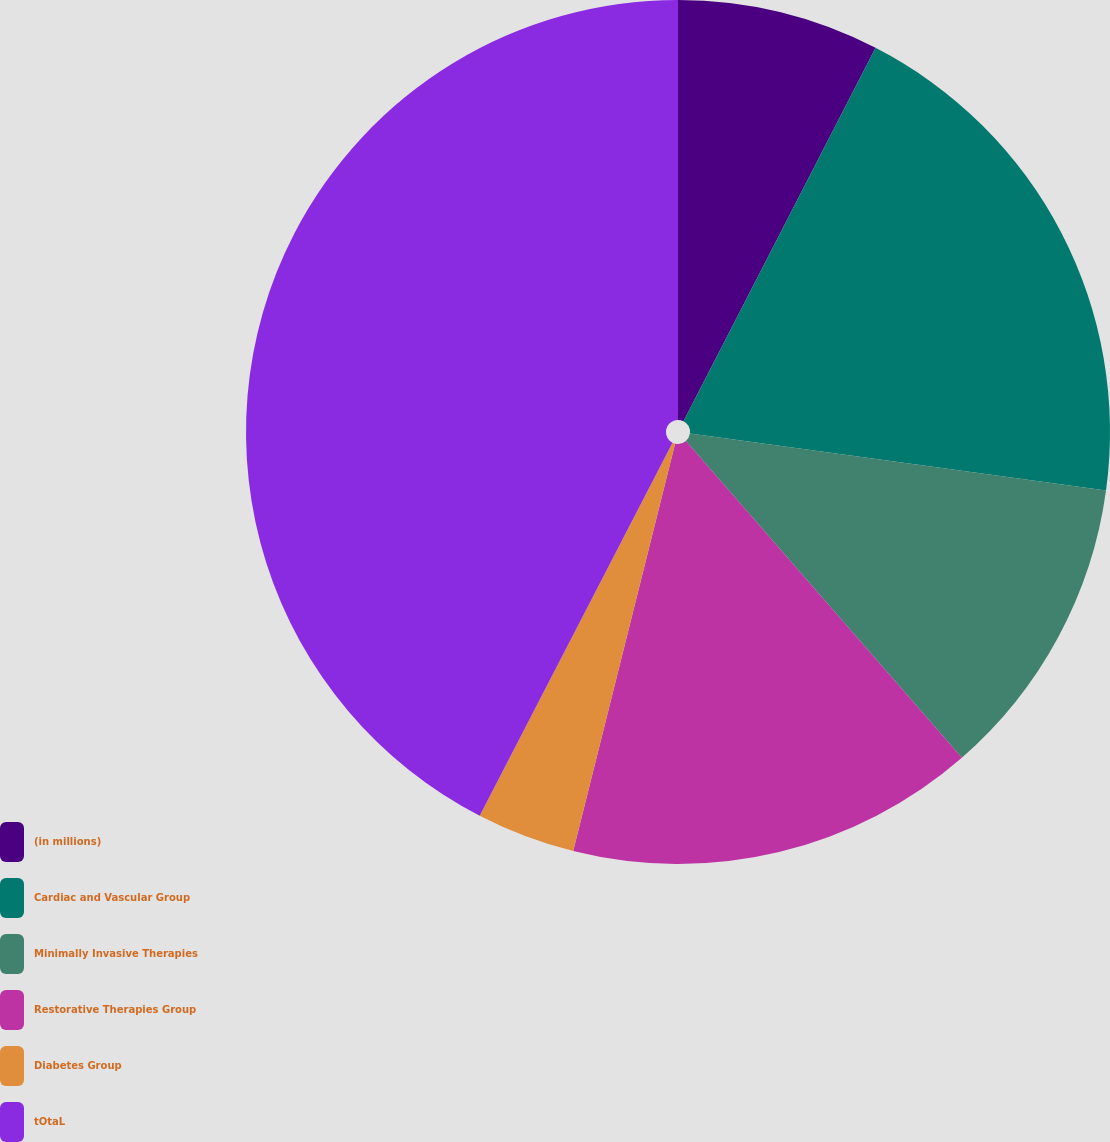Convert chart. <chart><loc_0><loc_0><loc_500><loc_500><pie_chart><fcel>(in millions)<fcel>Cardiac and Vascular Group<fcel>Minimally Invasive Therapies<fcel>Restorative Therapies Group<fcel>Diabetes Group<fcel>tOtaL<nl><fcel>7.56%<fcel>19.6%<fcel>11.43%<fcel>15.31%<fcel>3.69%<fcel>42.41%<nl></chart> 